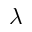<formula> <loc_0><loc_0><loc_500><loc_500>\lambda</formula> 